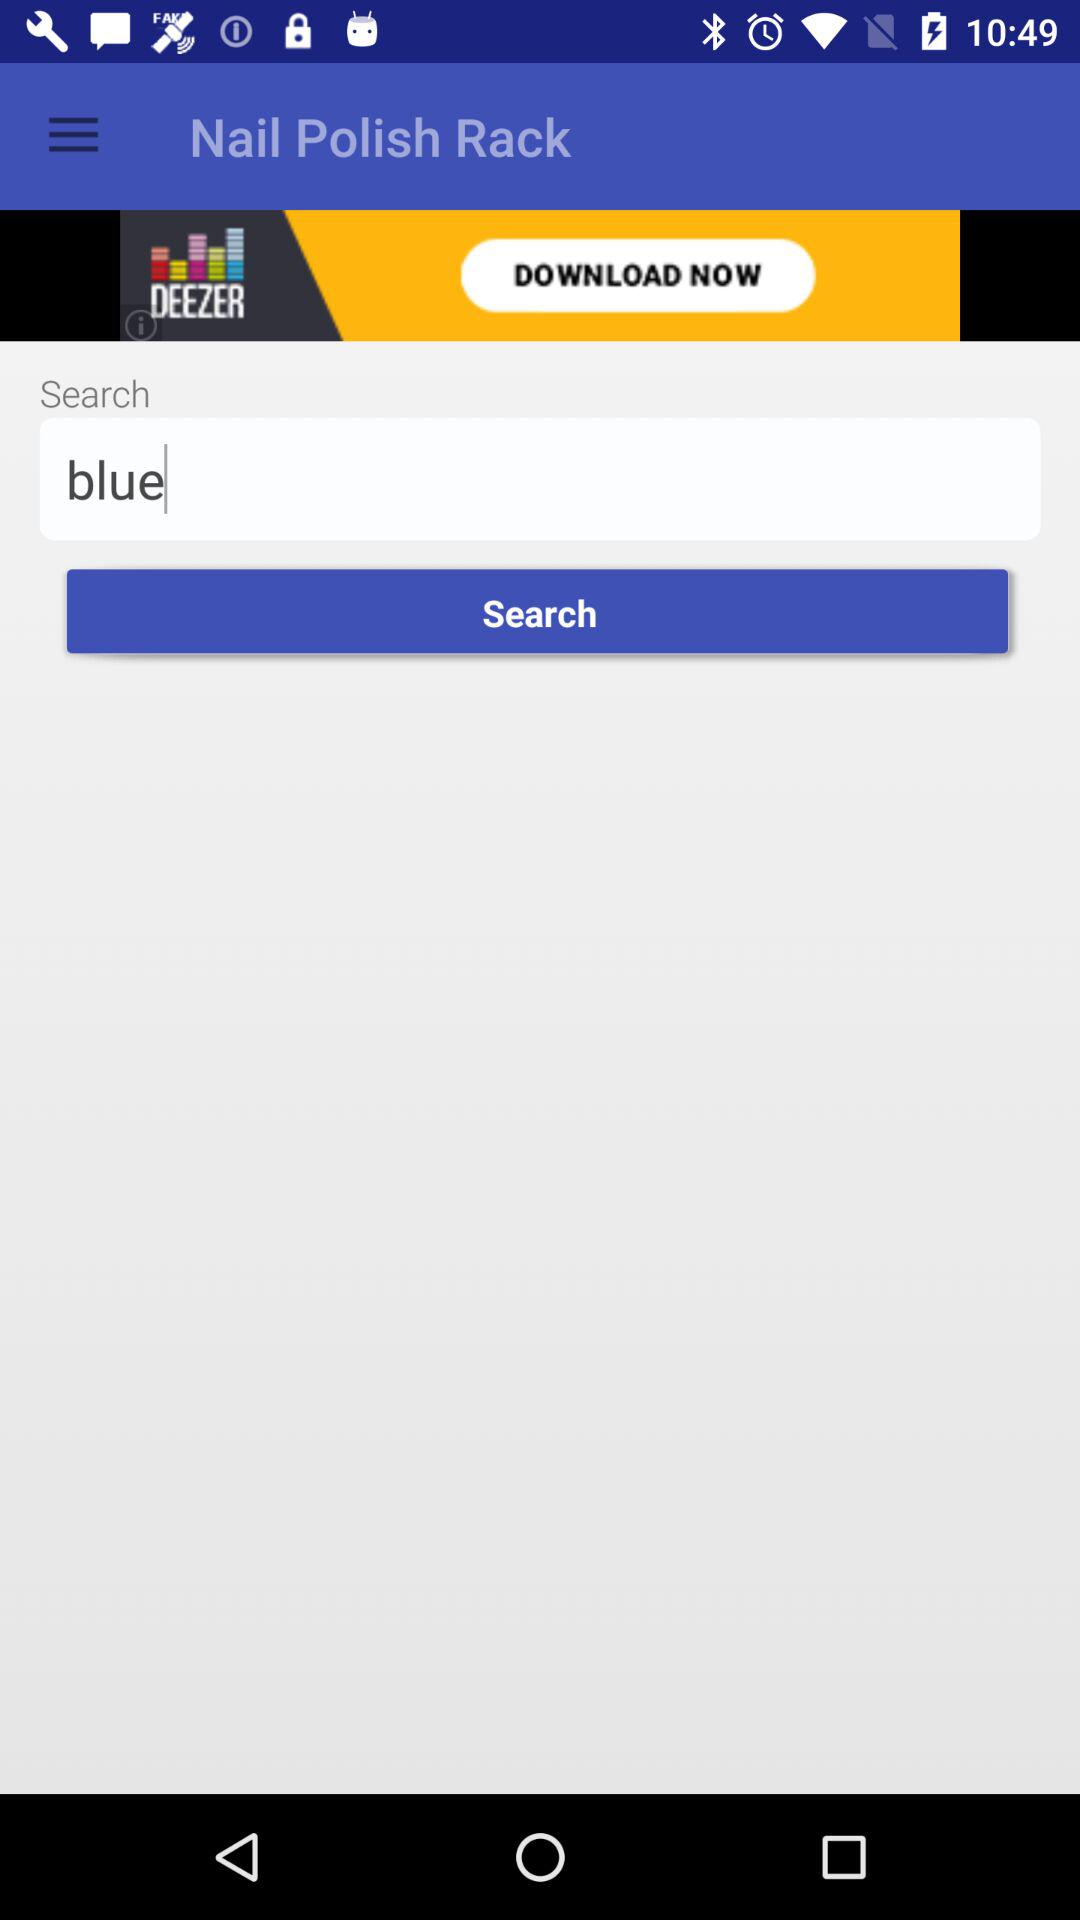What colors are written in the search box? The color that is written in the search box is "blue". 